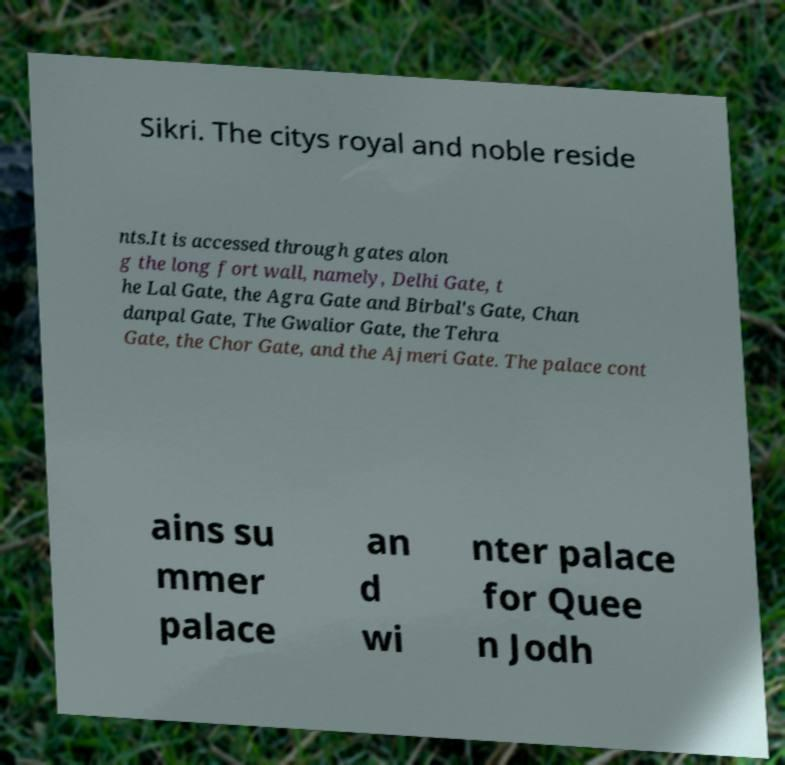For documentation purposes, I need the text within this image transcribed. Could you provide that? Sikri. The citys royal and noble reside nts.It is accessed through gates alon g the long fort wall, namely, Delhi Gate, t he Lal Gate, the Agra Gate and Birbal's Gate, Chan danpal Gate, The Gwalior Gate, the Tehra Gate, the Chor Gate, and the Ajmeri Gate. The palace cont ains su mmer palace an d wi nter palace for Quee n Jodh 